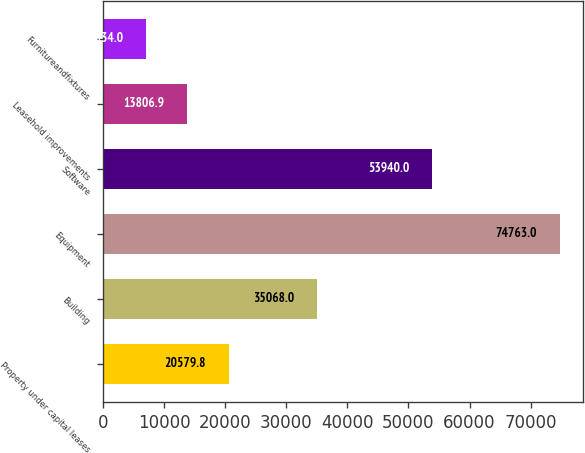Convert chart. <chart><loc_0><loc_0><loc_500><loc_500><bar_chart><fcel>Property under capital leases<fcel>Building<fcel>Equipment<fcel>Software<fcel>Leasehold improvements<fcel>Furnitureandfixtures<nl><fcel>20579.8<fcel>35068<fcel>74763<fcel>53940<fcel>13806.9<fcel>7034<nl></chart> 